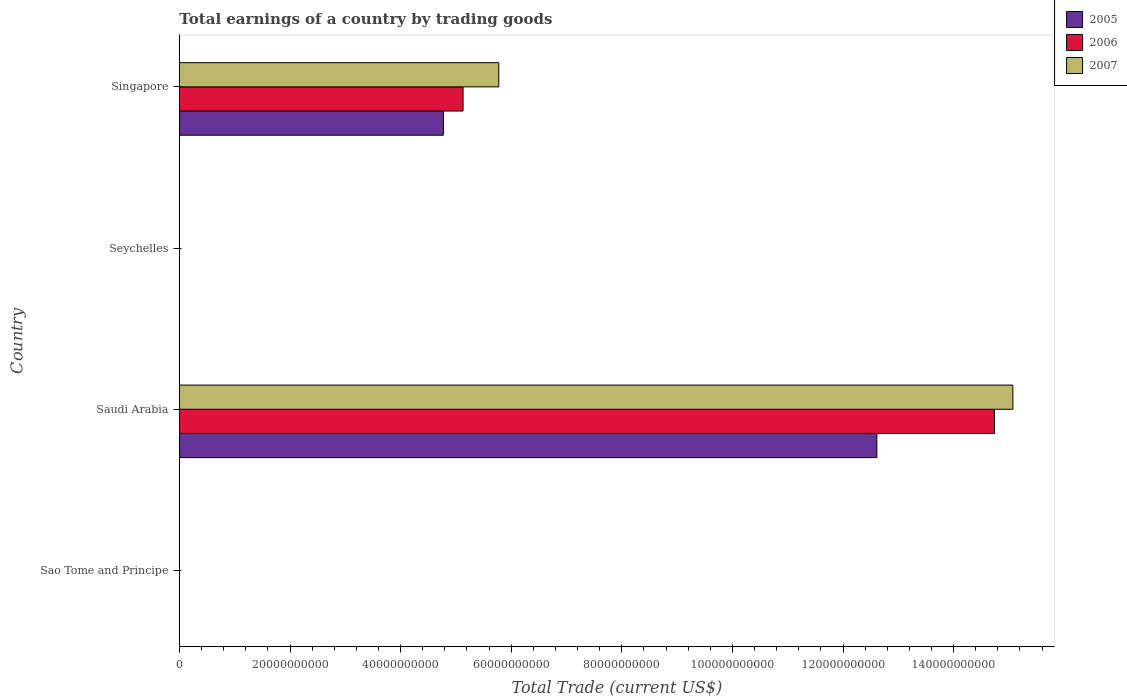How many different coloured bars are there?
Keep it short and to the point. 3. Are the number of bars per tick equal to the number of legend labels?
Give a very brief answer. No. Are the number of bars on each tick of the Y-axis equal?
Offer a terse response. No. How many bars are there on the 1st tick from the bottom?
Give a very brief answer. 0. What is the label of the 1st group of bars from the top?
Your answer should be compact. Singapore. What is the total earnings in 2007 in Saudi Arabia?
Ensure brevity in your answer.  1.51e+11. Across all countries, what is the maximum total earnings in 2007?
Keep it short and to the point. 1.51e+11. In which country was the total earnings in 2005 maximum?
Your answer should be very brief. Saudi Arabia. What is the total total earnings in 2006 in the graph?
Offer a very short reply. 1.99e+11. What is the difference between the total earnings in 2006 in Saudi Arabia and that in Singapore?
Give a very brief answer. 9.61e+1. What is the difference between the total earnings in 2006 in Singapore and the total earnings in 2005 in Sao Tome and Principe?
Your answer should be compact. 5.13e+1. What is the average total earnings in 2006 per country?
Your answer should be compact. 4.97e+1. What is the difference between the total earnings in 2007 and total earnings in 2006 in Saudi Arabia?
Your answer should be very brief. 3.32e+09. In how many countries, is the total earnings in 2006 greater than 136000000000 US$?
Offer a very short reply. 1. What is the difference between the highest and the lowest total earnings in 2005?
Your answer should be compact. 1.26e+11. In how many countries, is the total earnings in 2005 greater than the average total earnings in 2005 taken over all countries?
Make the answer very short. 2. Is it the case that in every country, the sum of the total earnings in 2005 and total earnings in 2007 is greater than the total earnings in 2006?
Your answer should be compact. No. How many bars are there?
Offer a very short reply. 6. Are the values on the major ticks of X-axis written in scientific E-notation?
Give a very brief answer. No. Does the graph contain grids?
Provide a short and direct response. No. What is the title of the graph?
Your response must be concise. Total earnings of a country by trading goods. What is the label or title of the X-axis?
Offer a terse response. Total Trade (current US$). What is the Total Trade (current US$) in 2005 in Sao Tome and Principe?
Your answer should be very brief. 0. What is the Total Trade (current US$) of 2006 in Sao Tome and Principe?
Make the answer very short. 0. What is the Total Trade (current US$) of 2007 in Sao Tome and Principe?
Your answer should be compact. 0. What is the Total Trade (current US$) of 2005 in Saudi Arabia?
Offer a very short reply. 1.26e+11. What is the Total Trade (current US$) in 2006 in Saudi Arabia?
Provide a succinct answer. 1.47e+11. What is the Total Trade (current US$) of 2007 in Saudi Arabia?
Offer a very short reply. 1.51e+11. What is the Total Trade (current US$) in 2005 in Seychelles?
Your answer should be compact. 0. What is the Total Trade (current US$) of 2005 in Singapore?
Give a very brief answer. 4.77e+1. What is the Total Trade (current US$) in 2006 in Singapore?
Provide a short and direct response. 5.13e+1. What is the Total Trade (current US$) of 2007 in Singapore?
Keep it short and to the point. 5.77e+1. Across all countries, what is the maximum Total Trade (current US$) in 2005?
Offer a terse response. 1.26e+11. Across all countries, what is the maximum Total Trade (current US$) of 2006?
Your answer should be very brief. 1.47e+11. Across all countries, what is the maximum Total Trade (current US$) in 2007?
Make the answer very short. 1.51e+11. Across all countries, what is the minimum Total Trade (current US$) in 2005?
Your answer should be compact. 0. Across all countries, what is the minimum Total Trade (current US$) of 2006?
Your answer should be very brief. 0. Across all countries, what is the minimum Total Trade (current US$) in 2007?
Give a very brief answer. 0. What is the total Total Trade (current US$) of 2005 in the graph?
Offer a very short reply. 1.74e+11. What is the total Total Trade (current US$) in 2006 in the graph?
Your answer should be very brief. 1.99e+11. What is the total Total Trade (current US$) in 2007 in the graph?
Provide a short and direct response. 2.08e+11. What is the difference between the Total Trade (current US$) of 2005 in Saudi Arabia and that in Singapore?
Keep it short and to the point. 7.84e+1. What is the difference between the Total Trade (current US$) of 2006 in Saudi Arabia and that in Singapore?
Give a very brief answer. 9.61e+1. What is the difference between the Total Trade (current US$) in 2007 in Saudi Arabia and that in Singapore?
Make the answer very short. 9.30e+1. What is the difference between the Total Trade (current US$) of 2005 in Saudi Arabia and the Total Trade (current US$) of 2006 in Singapore?
Provide a short and direct response. 7.48e+1. What is the difference between the Total Trade (current US$) of 2005 in Saudi Arabia and the Total Trade (current US$) of 2007 in Singapore?
Your answer should be compact. 6.84e+1. What is the difference between the Total Trade (current US$) in 2006 in Saudi Arabia and the Total Trade (current US$) in 2007 in Singapore?
Provide a succinct answer. 8.96e+1. What is the average Total Trade (current US$) of 2005 per country?
Your answer should be very brief. 4.35e+1. What is the average Total Trade (current US$) of 2006 per country?
Provide a succinct answer. 4.97e+1. What is the average Total Trade (current US$) in 2007 per country?
Keep it short and to the point. 5.21e+1. What is the difference between the Total Trade (current US$) in 2005 and Total Trade (current US$) in 2006 in Saudi Arabia?
Your answer should be compact. -2.13e+1. What is the difference between the Total Trade (current US$) of 2005 and Total Trade (current US$) of 2007 in Saudi Arabia?
Give a very brief answer. -2.46e+1. What is the difference between the Total Trade (current US$) in 2006 and Total Trade (current US$) in 2007 in Saudi Arabia?
Your response must be concise. -3.32e+09. What is the difference between the Total Trade (current US$) of 2005 and Total Trade (current US$) of 2006 in Singapore?
Keep it short and to the point. -3.55e+09. What is the difference between the Total Trade (current US$) of 2005 and Total Trade (current US$) of 2007 in Singapore?
Your answer should be compact. -1.00e+1. What is the difference between the Total Trade (current US$) of 2006 and Total Trade (current US$) of 2007 in Singapore?
Provide a short and direct response. -6.46e+09. What is the ratio of the Total Trade (current US$) of 2005 in Saudi Arabia to that in Singapore?
Offer a terse response. 2.64. What is the ratio of the Total Trade (current US$) in 2006 in Saudi Arabia to that in Singapore?
Provide a succinct answer. 2.87. What is the ratio of the Total Trade (current US$) in 2007 in Saudi Arabia to that in Singapore?
Offer a very short reply. 2.61. What is the difference between the highest and the lowest Total Trade (current US$) in 2005?
Offer a terse response. 1.26e+11. What is the difference between the highest and the lowest Total Trade (current US$) in 2006?
Offer a terse response. 1.47e+11. What is the difference between the highest and the lowest Total Trade (current US$) of 2007?
Offer a terse response. 1.51e+11. 